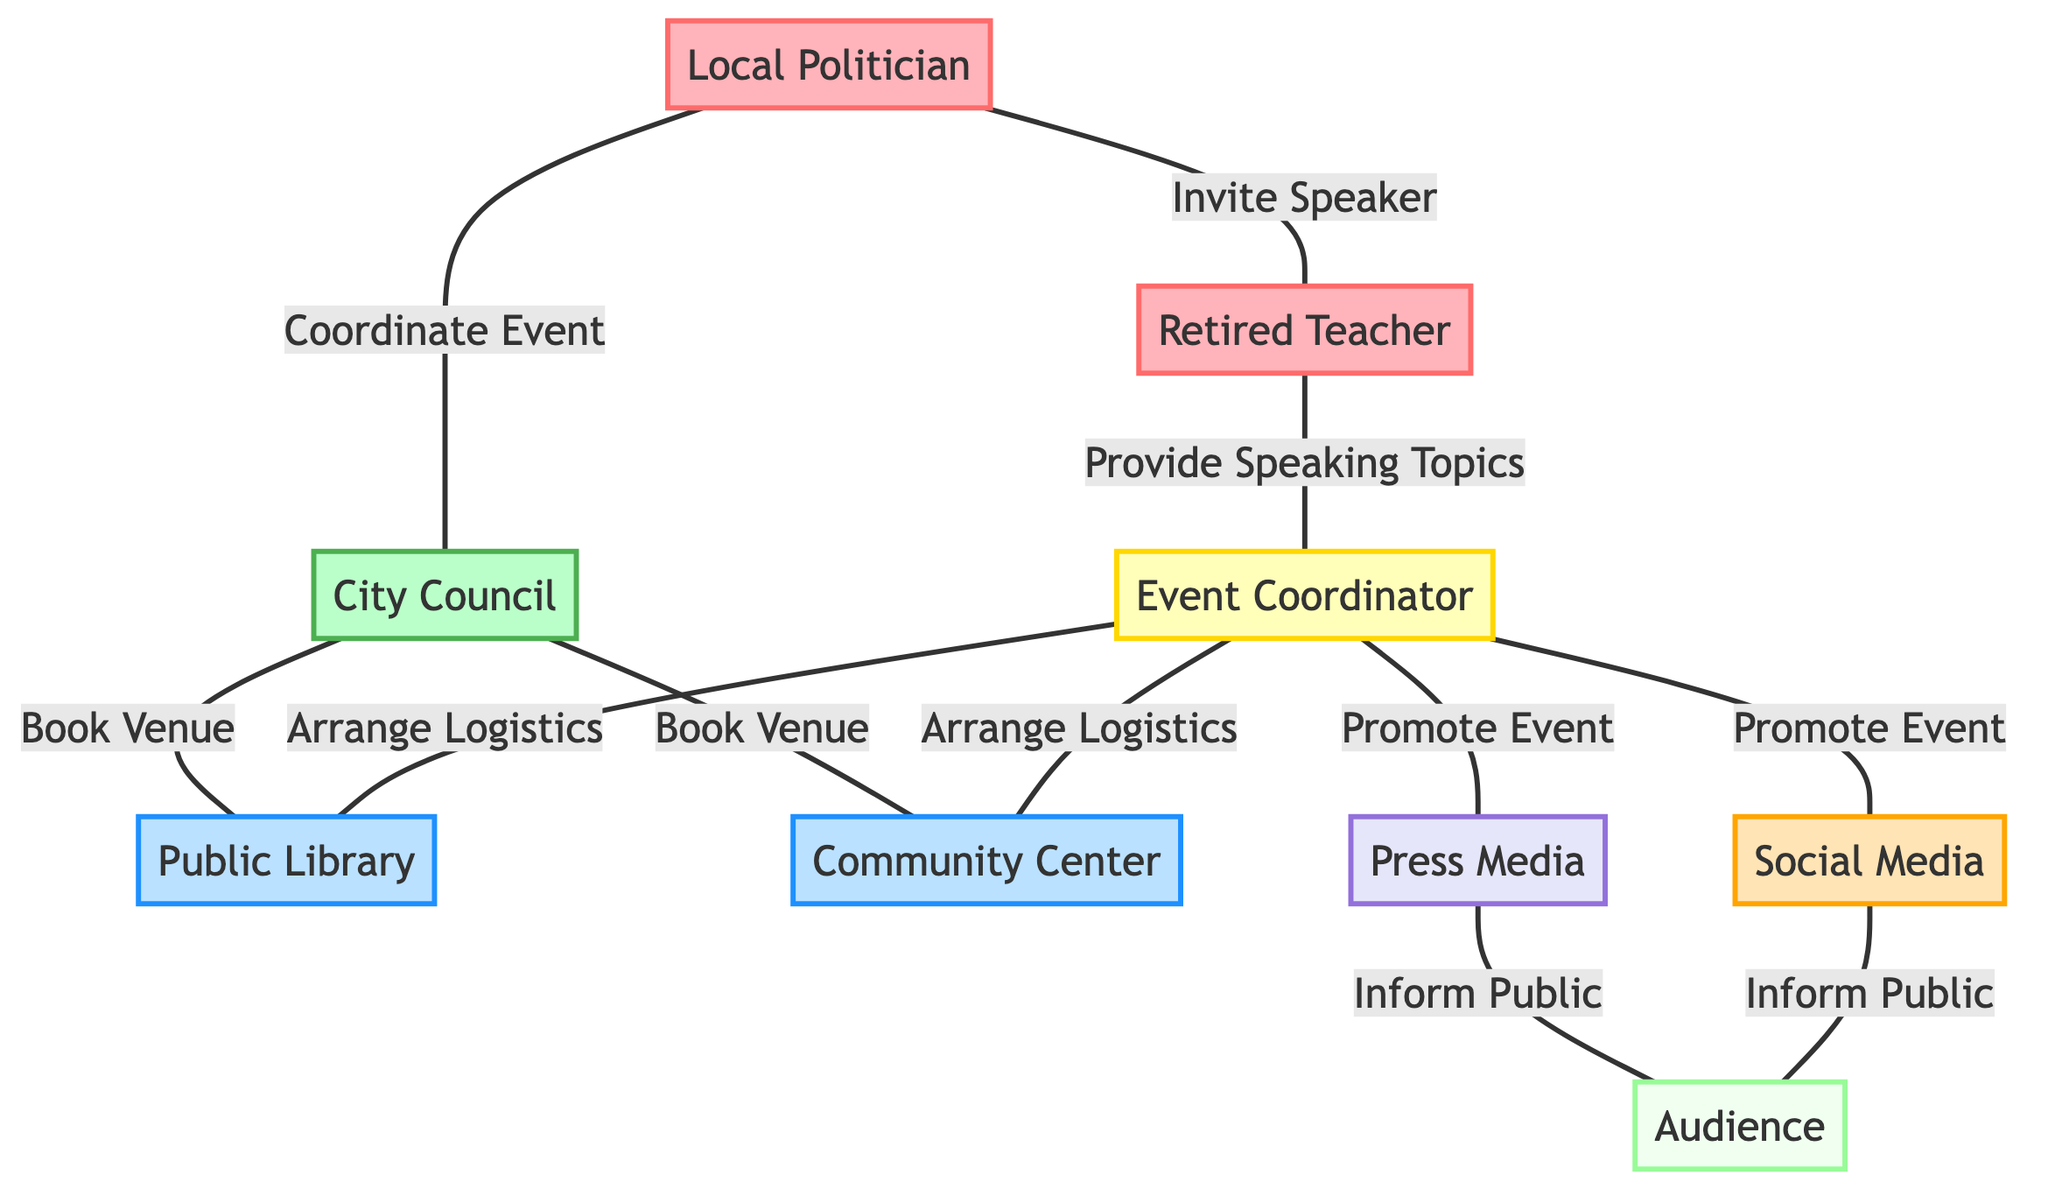What are the total number of nodes in the graph? The graph has a total of 9 nodes which are: Local Politician, Retired Teacher, City Council, Public Library, Community Center, Event Coordinator, Press Media, Social Media, and Audience.
Answer: 9 Who is responsible for inviting the speaker in the event organization? The Local Politician is indicated to invite the Retired Teacher as a speaker in the diagram.
Answer: Local Politician Which venues are booked by the City Council? The City Council books two venues: the Public Library and the Community Center, both of which are shown connected by edges labeled "Book Venue."
Answer: Public Library, Community Center What connection does the Event Coordinator have with the audience? The Event Coordinator is linked to both Press Media and Social Media, which in turn both inform the Audience, indicating that the Event Coordinator plays a key role in promoting the event to the Audience.
Answer: Promote Event How many entities are responsible for informing the audience? There are two entities responsible for informing the audience: Press Media and Social Media, as shown by the edges labeled "Inform Public" connecting them to the Audience.
Answer: 2 What role does the Retired Teacher play in the event organization process? The Retired Teacher provides speaking topics to the Event Coordinator, which is indicated by the connection labeled "Provide Speaking Topics."
Answer: Provide Speaking Topics Which role is responsible for arranging logistics for the venues? The Event Coordinator is shown to arrange logistics for both the Public Library and Community Center, as evidenced by the edges leading to each venue with the label "Arrange Logistics."
Answer: Event Coordinator What type of relationship connects the Local Politician and the City Council? The Local Politician coordinates the event with the City Council, as indicated by the edge labeled "Coordinate Event."
Answer: Coordinate Event In what ways can the Event Coordinator promote the event? The Event Coordinator promotes the event through both Press Media and Social Media platforms, providing two avenues for event promotion as shown by the corresponding edges.
Answer: Press Media, Social Media 